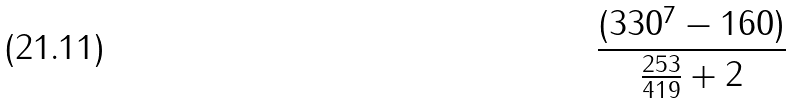<formula> <loc_0><loc_0><loc_500><loc_500>\frac { ( 3 3 0 ^ { 7 } - 1 6 0 ) } { \frac { 2 5 3 } { 4 1 9 } + 2 }</formula> 